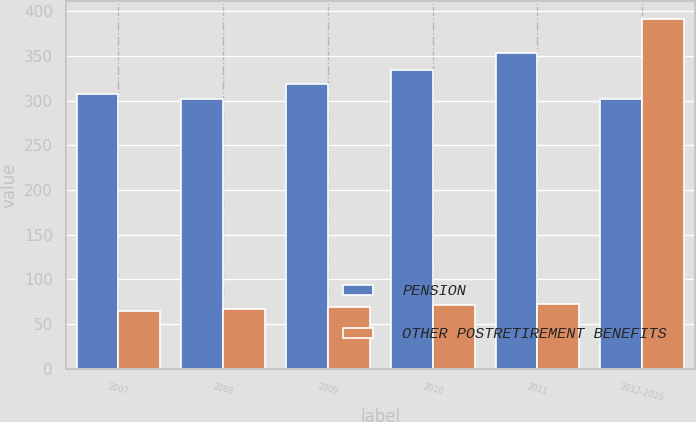<chart> <loc_0><loc_0><loc_500><loc_500><stacked_bar_chart><ecel><fcel>2007<fcel>2008<fcel>2009<fcel>2010<fcel>2011<fcel>2012-2016<nl><fcel>PENSION<fcel>308<fcel>302<fcel>319<fcel>334<fcel>353<fcel>302<nl><fcel>OTHER POSTRETIREMENT BENEFITS<fcel>65<fcel>67<fcel>69<fcel>71<fcel>73<fcel>392<nl></chart> 